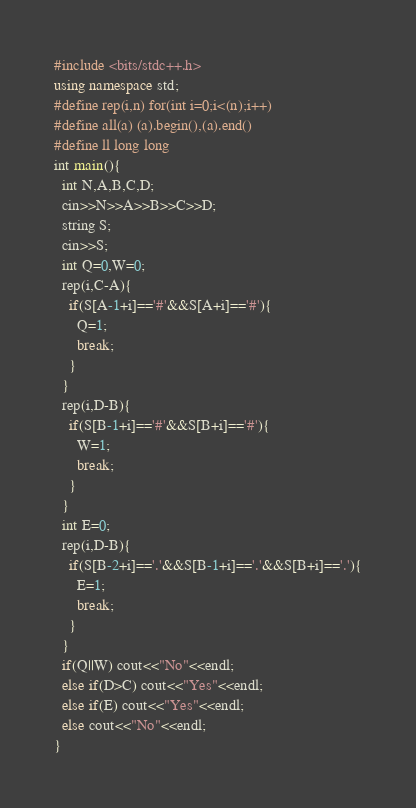<code> <loc_0><loc_0><loc_500><loc_500><_C++_>#include <bits/stdc++.h>
using namespace std;
#define rep(i,n) for(int i=0;i<(n);i++)
#define all(a) (a).begin(),(a).end()
#define ll long long
int main(){
  int N,A,B,C,D;
  cin>>N>>A>>B>>C>>D;
  string S;
  cin>>S;
  int Q=0,W=0;
  rep(i,C-A){
    if(S[A-1+i]=='#'&&S[A+i]=='#'){
      Q=1;
      break;
    }
  }
  rep(i,D-B){
    if(S[B-1+i]=='#'&&S[B+i]=='#'){
      W=1;
      break;
    }
  }
  int E=0;
  rep(i,D-B){
    if(S[B-2+i]=='.'&&S[B-1+i]=='.'&&S[B+i]=='.'){
      E=1;
      break;
    }
  }
  if(Q||W) cout<<"No"<<endl;
  else if(D>C) cout<<"Yes"<<endl;
  else if(E) cout<<"Yes"<<endl;
  else cout<<"No"<<endl;
}</code> 